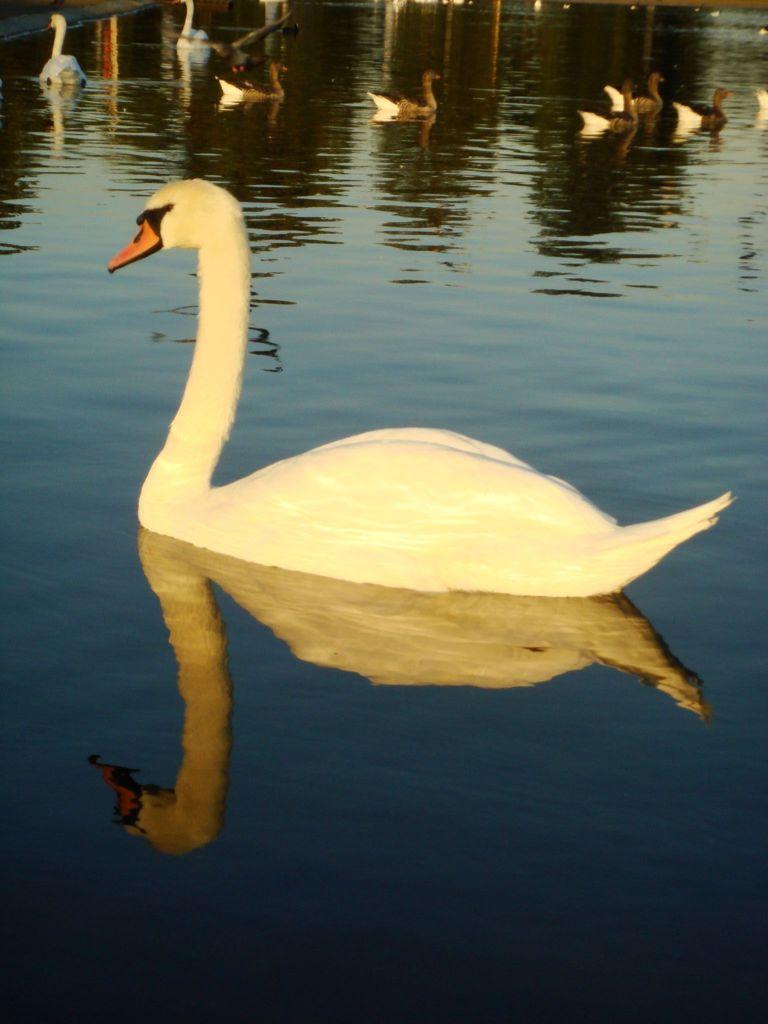Describe this image in one or two sentences. Here in this picture we can see number of swans present in water. 